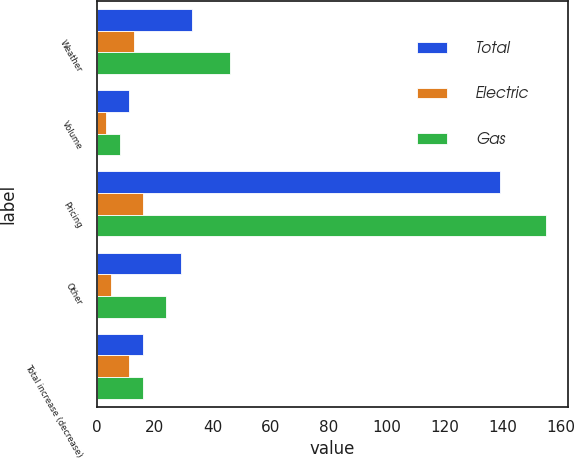<chart> <loc_0><loc_0><loc_500><loc_500><stacked_bar_chart><ecel><fcel>Weather<fcel>Volume<fcel>Pricing<fcel>Other<fcel>Total increase (decrease)<nl><fcel>Total<fcel>33<fcel>11<fcel>139<fcel>29<fcel>16<nl><fcel>Electric<fcel>13<fcel>3<fcel>16<fcel>5<fcel>11<nl><fcel>Gas<fcel>46<fcel>8<fcel>155<fcel>24<fcel>16<nl></chart> 